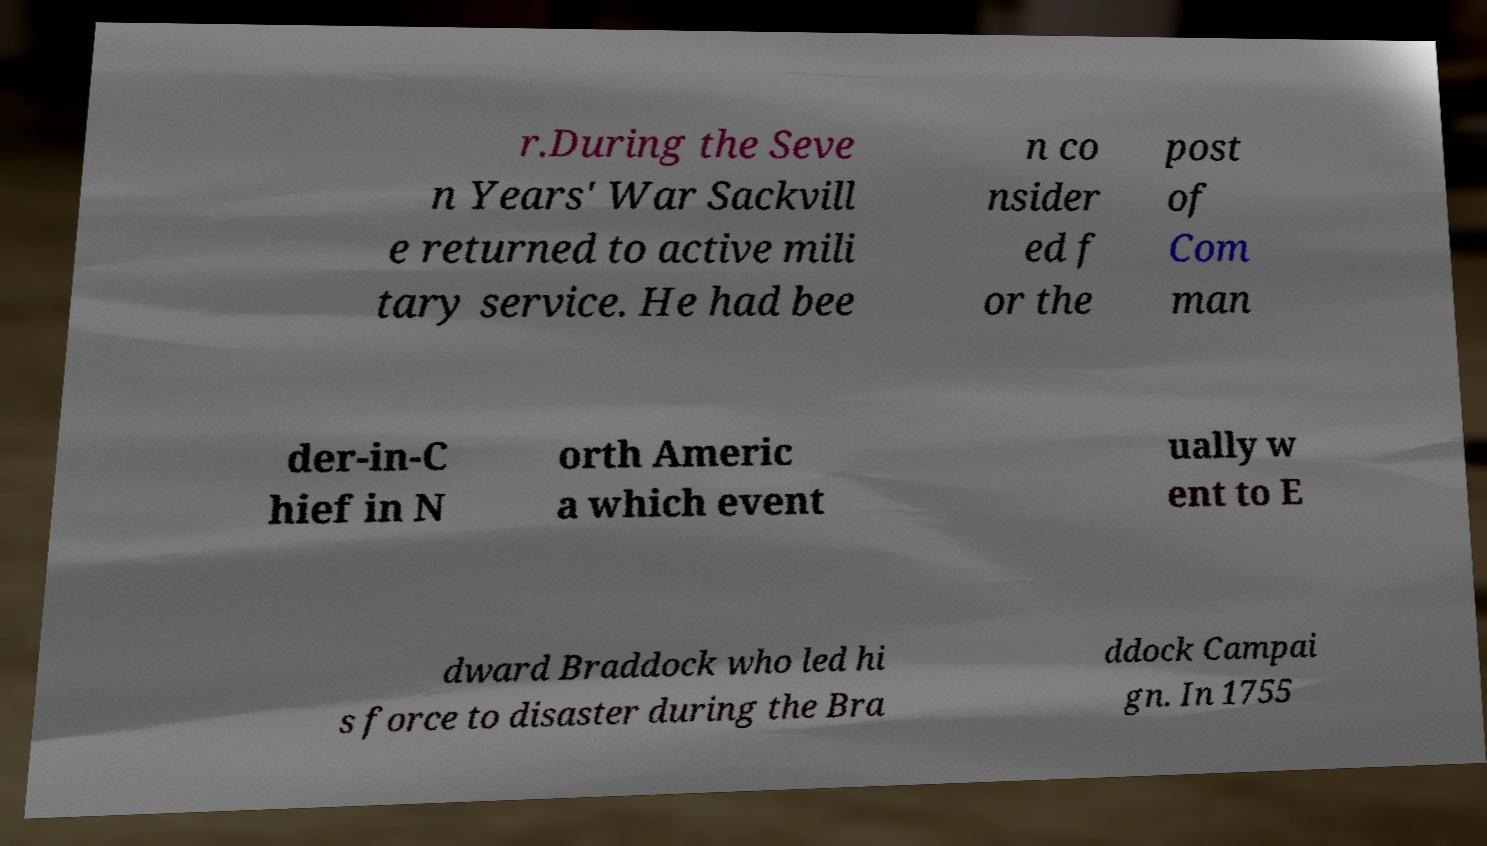Please identify and transcribe the text found in this image. r.During the Seve n Years' War Sackvill e returned to active mili tary service. He had bee n co nsider ed f or the post of Com man der-in-C hief in N orth Americ a which event ually w ent to E dward Braddock who led hi s force to disaster during the Bra ddock Campai gn. In 1755 